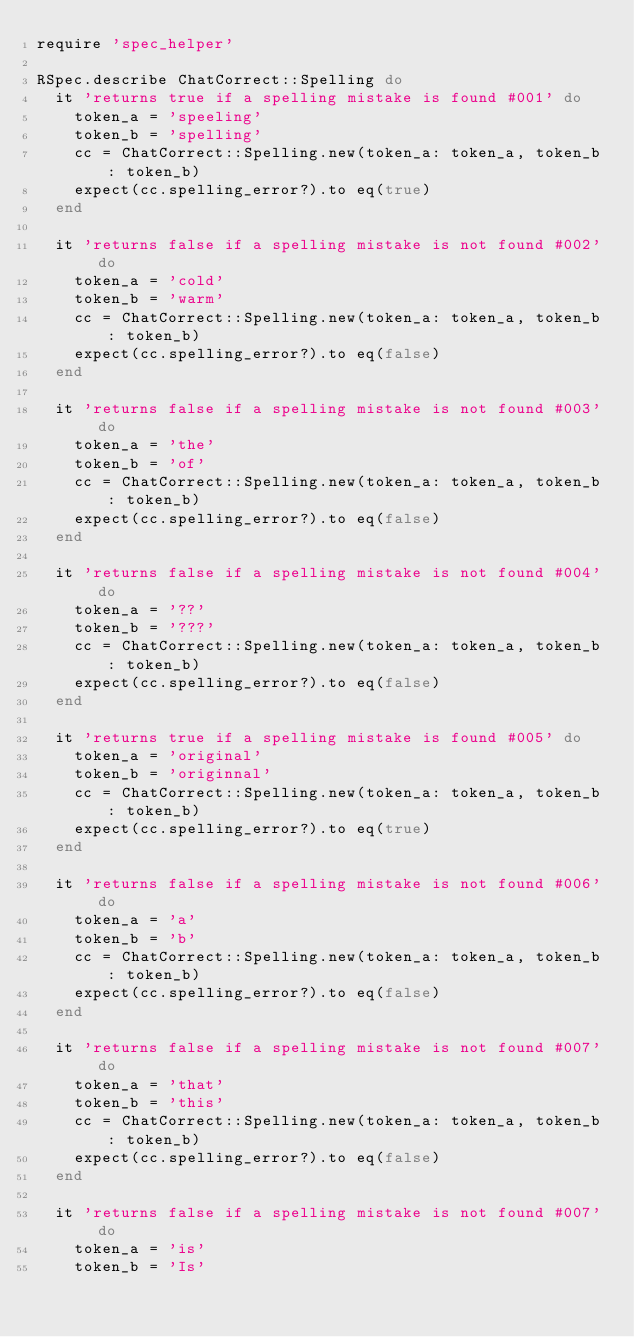<code> <loc_0><loc_0><loc_500><loc_500><_Ruby_>require 'spec_helper'

RSpec.describe ChatCorrect::Spelling do
  it 'returns true if a spelling mistake is found #001' do
    token_a = 'speeling'
    token_b = 'spelling'
    cc = ChatCorrect::Spelling.new(token_a: token_a, token_b: token_b)
    expect(cc.spelling_error?).to eq(true)
  end

  it 'returns false if a spelling mistake is not found #002' do
    token_a = 'cold'
    token_b = 'warm'
    cc = ChatCorrect::Spelling.new(token_a: token_a, token_b: token_b)
    expect(cc.spelling_error?).to eq(false)
  end

  it 'returns false if a spelling mistake is not found #003' do
    token_a = 'the'
    token_b = 'of'
    cc = ChatCorrect::Spelling.new(token_a: token_a, token_b: token_b)
    expect(cc.spelling_error?).to eq(false)
  end

  it 'returns false if a spelling mistake is not found #004' do
    token_a = '??'
    token_b = '???'
    cc = ChatCorrect::Spelling.new(token_a: token_a, token_b: token_b)
    expect(cc.spelling_error?).to eq(false)
  end

  it 'returns true if a spelling mistake is found #005' do
    token_a = 'original'
    token_b = 'originnal'
    cc = ChatCorrect::Spelling.new(token_a: token_a, token_b: token_b)
    expect(cc.spelling_error?).to eq(true)
  end

  it 'returns false if a spelling mistake is not found #006' do
    token_a = 'a'
    token_b = 'b'
    cc = ChatCorrect::Spelling.new(token_a: token_a, token_b: token_b)
    expect(cc.spelling_error?).to eq(false)
  end

  it 'returns false if a spelling mistake is not found #007' do
    token_a = 'that'
    token_b = 'this'
    cc = ChatCorrect::Spelling.new(token_a: token_a, token_b: token_b)
    expect(cc.spelling_error?).to eq(false)
  end

  it 'returns false if a spelling mistake is not found #007' do
    token_a = 'is'
    token_b = 'Is'</code> 